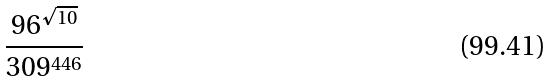<formula> <loc_0><loc_0><loc_500><loc_500>\frac { 9 6 ^ { \sqrt { 1 0 } } } { 3 0 9 ^ { 4 4 6 } }</formula> 